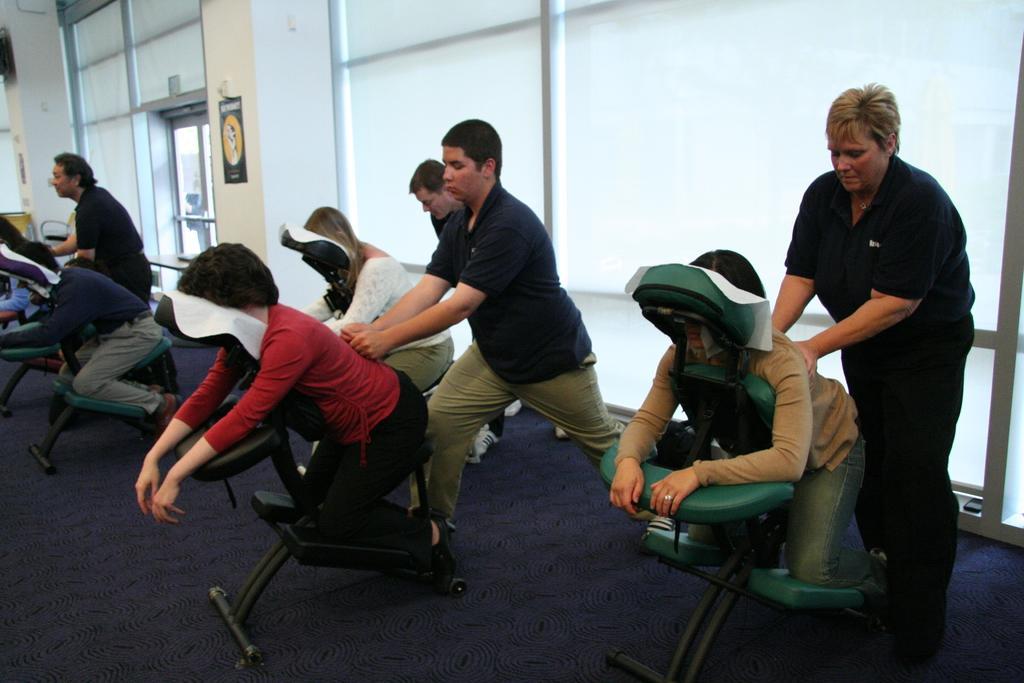Describe this image in one or two sentences. In the image few people were taking the massage therapy and behind them there are many windows and there are two pillars in between the windows. 